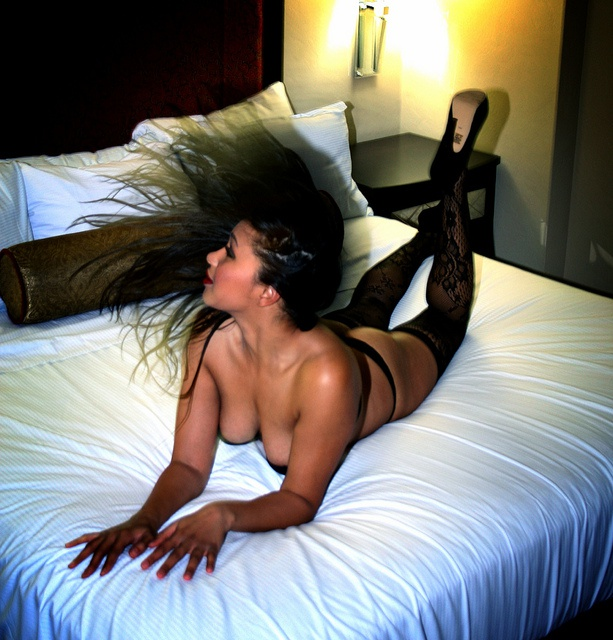Describe the objects in this image and their specific colors. I can see bed in black, lightgray, lightblue, and darkgray tones and people in black, maroon, and brown tones in this image. 